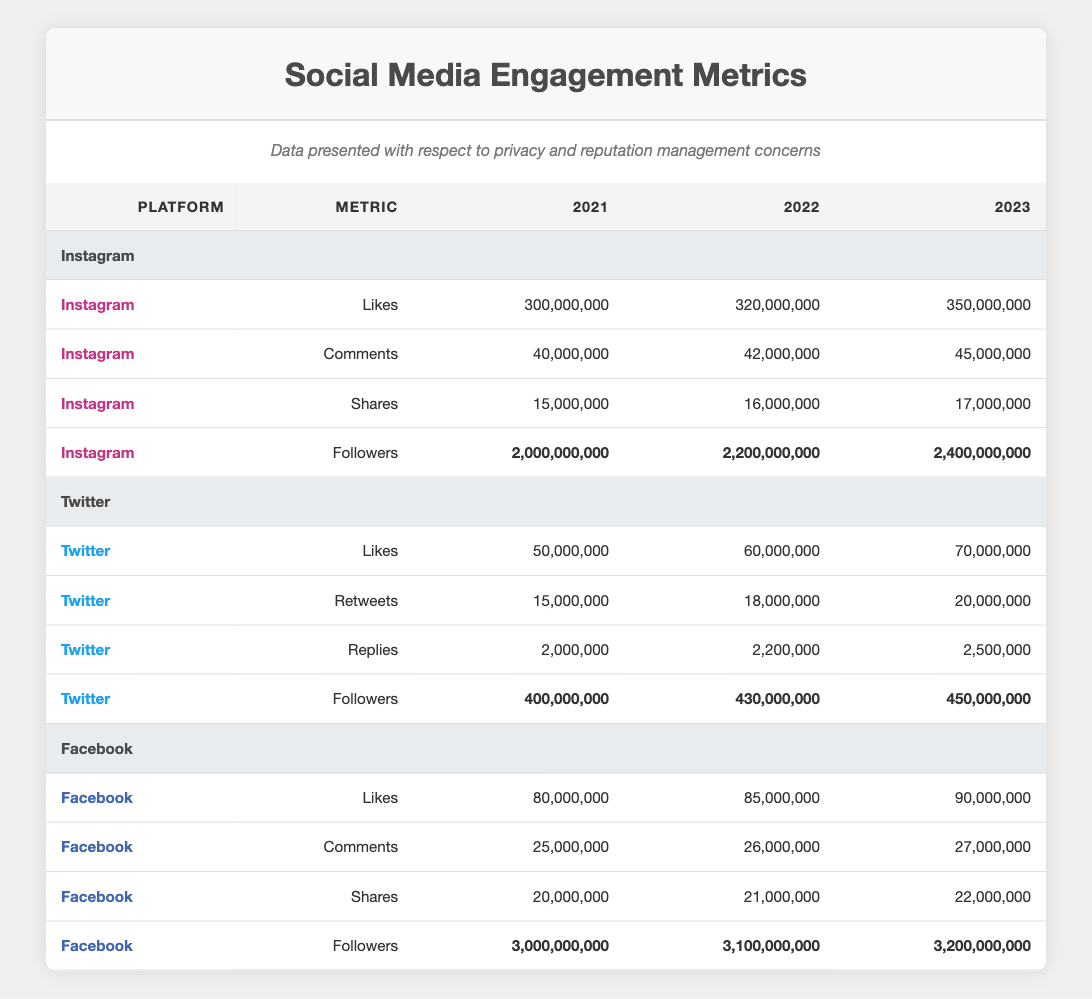What were the total Likes on Instagram in 2022? From the table, the Likes on Instagram for 2022 is listed as 320,000,000.
Answer: 320,000,000 How many Followers did Twitter gain from 2021 to 2023? In 2021, Twitter had 400,000,000 Followers, and in 2023 it had 450,000,000 Followers. The gain is 450,000,000 - 400,000,000 = 50,000,000.
Answer: 50,000,000 Did Facebook have more Likes in 2021 compared to Twitter in the same year? Facebook's Likes in 2021 were 80,000,000 and Twitter's were 50,000,000. Since 80,000,000 is greater than 50,000,000, the statement is true.
Answer: Yes What is the average number of Comments across all platforms in 2023? For 2023, the Comments are as follows: Instagram had 45,000,000, Twitter had an unspecified number so we'll leave that out, and Facebook had 27,000,000. If we only consider Instagram and Facebook, the total is 72,000,000 for two platforms, so the average is 72,000,000 / 2 = 36,000,000.
Answer: 36,000,000 Which platform had the highest increase in Followers from 2021 to 2023? Instagram had Followers of 2,000,000,000 in 2021 and 2,400,000,000 in 2023, which is an increase of 400,000,000. Twitter went from 400,000,000 to 450,000,000 (a 50,000,000 increase), and Facebook went from 3,000,000,000 to 3,200,000,000 (a 200,000,000 increase). Thus, Instagram had the highest increase.
Answer: Instagram How many more Shares did Instagram have in 2023 compared to Facebook? Instagram's Shares in 2023 were 17,000,000, and Facebook's were 22,000,000. The difference is 17,000,000 - 22,000,000 = -5,000,000, meaning Instagram had 5,000,000 fewer Shares than Facebook.
Answer: Instagram had 5,000,000 fewer Shares 